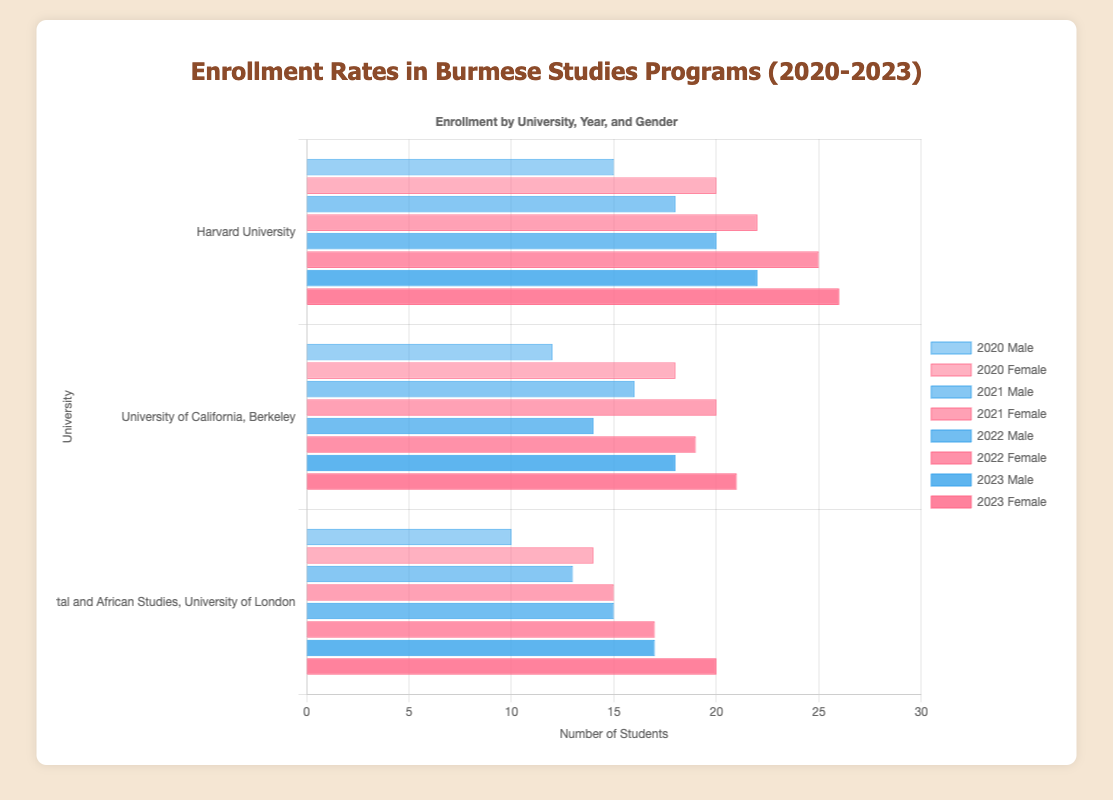Which university had the highest male enrollment in 2023? In the visualized data for 2023, compare the heights of the blue bars corresponding to male enrollment across the three universities. Harvard University has the highest bar.
Answer: Harvard University What was the female enrollment at the University of California, Berkeley in 2021? Look for the red bar labeled "2021 Female" for the University of California, Berkeley, and note its height.
Answer: 20 Between Harvard University and the School of Oriental and African Studies in 2022, which had a higher total enrollment of males and how much higher was it? Sum the male enrollments for both universities in 2022: Harvard University (20 males) and School of Oriental and African Studies (15 males). Harvard University had a higher enrollment by 5 students.
Answer: Harvard University, 5 Which university showed the greatest increase in female enrollment from 2020 to 2023? Calculate the difference in female enrollment between 2020 and 2023 for each university:
- Harvard University: 26 - 20 = 6
- University of California, Berkeley: 21 - 18 = 3
- School of Oriental and African Studies: 20 - 14 = 6
Harvard University and SOAS both show an increase of 6.
Answer: Harvard University and SOAS, 6 Did the male enrollment at Harvard University increase or decrease from 2020 to 2021, and by how much? Compare the heights of the blue bars labeled "2020 Male" and "2021 Male" for Harvard University: 18 - 15 = 3. The enrollment increased.
Answer: Increased, 3 What's the average female enrollment at School of Oriental and African Studies from 2020 to 2023? Average is calculated by summing the female enrollments and dividing by the number of years: (14 + 15 + 17 + 20) / 4 = 16.5.
Answer: 16.5 Which gender had higher enrollment at University of California, Berkeley in 2022 and by how much? Compare the red (female) and blue (male) bars for University of California, Berkeley in 2022: 19 - 14 = 5. Female enrollment was higher.
Answer: Female, 5 Which university had the lowest female enrollment in 2020? Compare the heights of the red bars corresponding to 2020 Female across the three universities. The School of Oriental and African Studies has the lowest.
Answer: School of Oriental and African Studies Across all years, which university showed the most consistent male enrollment numbers? Evaluate the blue bars for male enrollment from 2020 to 2023 for each university and note the consistency in their height. The University of California, Berkeley shows the most consistent male enrollment numbers at a range of mostly 12 to 18.
Answer: University of California, Berkeley 